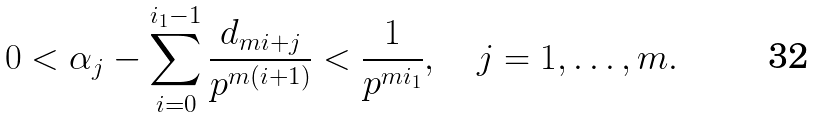<formula> <loc_0><loc_0><loc_500><loc_500>0 < \alpha _ { j } - \sum _ { i = 0 } ^ { i _ { 1 } - 1 } \frac { d _ { m i + j } } { p ^ { m ( i + 1 ) } } < \frac { 1 } { p ^ { m i _ { 1 } } } , \quad j = 1 , \dots , m .</formula> 